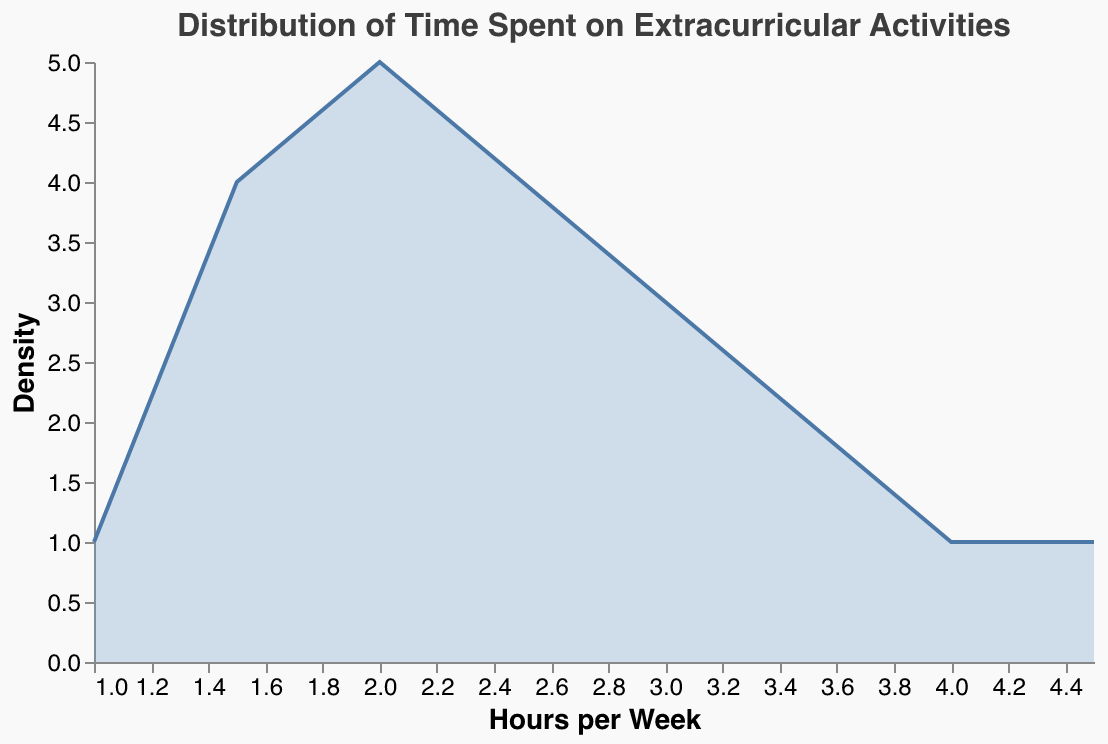What is the title of the plot? The title of the plot can be found at the top and generally gives us an idea of what the plot is about. By looking at the top, we can see the title text.
Answer: Distribution of Time Spent on Extracurricular Activities What is the color used to represent the density area in the plot? The color representing the density area can be identified by observing the filled area of the plot.
Answer: Light blue (#6b9ac4 with fill opacity) How many activities have more than 3 hours per week in duration? To find the number of activities with more than 3 hours per week, we look at the x-axis and count how many bars extend beyond the 3-hour mark.
Answer: 5 What is the most common duration range for extracurricular activities? To determine the most common duration range, we need to see where the density plot peaks, indicating the highest count of activities.
Answer: 2-2.5 hours per week Which activity has the maximum duration in hours per week, and what is it? To find which activity has the maximum duration, observe the x-axis values and identify the highest one along with the corresponding activity.
Answer: Drama Club Rehearsals, 4.5 hours How does the density of activities with 1.5 hours compare to those with 2 hours per week? To compare the density, observe the height of the density plot at 1.5 hours and at 2 hours to see which is higher.
Answer: The density is higher at 2 hours per week compared to 1.5 hours What's the median duration of time spent on extracurricular activities? To find the median, sort the durations in ascending order and find the middle value. Here, we have 21 values, so the median is the 11th value when sorted. The sorted durations are: 1, 1.5, 1.5, 1.5, 1.5, 2, 2, 2, 2, 2, 2.5, 2.5, 2.5, 2.5, 3, 3, 3, 3.5, 3.5, 4, 4.5. The 11th value is 2.5.
Answer: 2.5 hours Compare the density of activities with 3 hours per week and 4 hours per week. Which one is higher? To determine which duration has a higher density, compare the height of the density plot line at both 3 hours and 4 hours per week.
Answer: 3 hours per week How many activities fall within the duration range of 2 to 3 hours per week? To find the number of activities between 2 and 3 hours, count the activities within this range by referring to the x-axis and the corresponding areas in this range.
Answer: 10 What is the average duration of time spent on extracurricular activities? To find the average, sum all the durations and divide by the number of activities. The sum of durations = 2 + 4 + 3 + 2.5 + 1.5 + 2 + 3 + 4.5 + 2.5 + 3.5 + 1.5 + 2 + 1 + 1.5 + 3.5 + 2 + 3 + 1.5 + 2.5 + 2.5. Adding these gives 51.5. The number of activities is 21. 51.5 / 21 ≈ 2.45.
Answer: 2.45 hours Which range shows the smallest density in the plot? To find the range with the smallest density, look for the lowest point(s) in the density plot.
Answer: 4.5 hours 